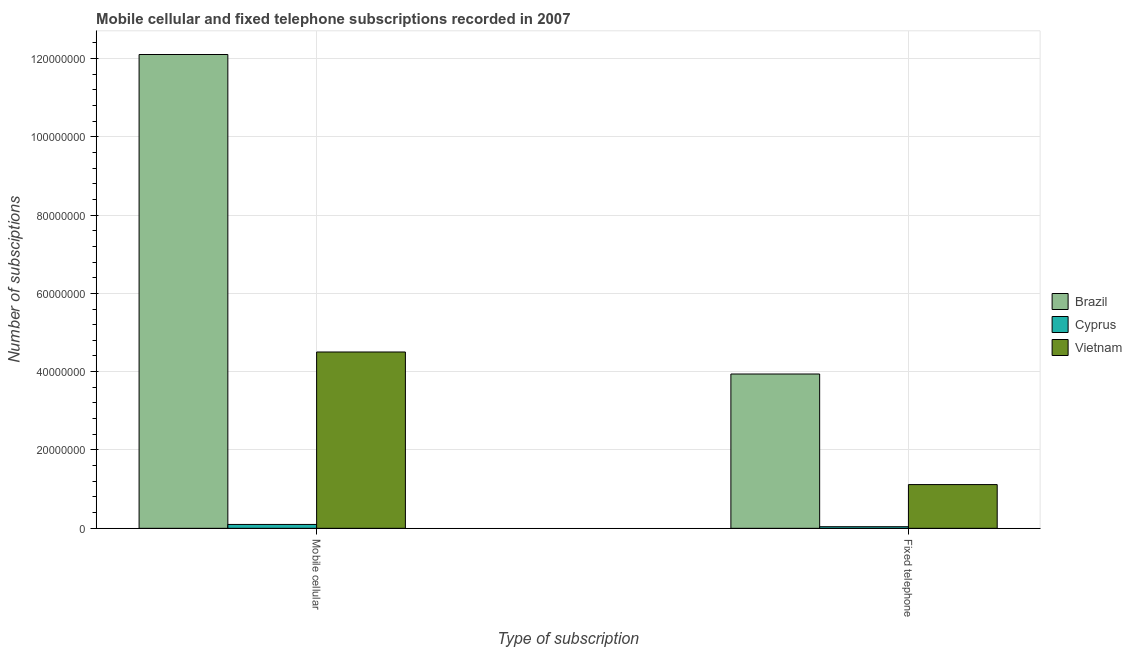How many different coloured bars are there?
Make the answer very short. 3. Are the number of bars per tick equal to the number of legend labels?
Your answer should be compact. Yes. How many bars are there on the 2nd tick from the left?
Offer a terse response. 3. What is the label of the 2nd group of bars from the left?
Offer a terse response. Fixed telephone. What is the number of mobile cellular subscriptions in Cyprus?
Your answer should be compact. 9.88e+05. Across all countries, what is the maximum number of fixed telephone subscriptions?
Your answer should be very brief. 3.94e+07. Across all countries, what is the minimum number of mobile cellular subscriptions?
Your answer should be compact. 9.88e+05. In which country was the number of fixed telephone subscriptions maximum?
Provide a succinct answer. Brazil. In which country was the number of mobile cellular subscriptions minimum?
Give a very brief answer. Cyprus. What is the total number of fixed telephone subscriptions in the graph?
Offer a terse response. 5.10e+07. What is the difference between the number of fixed telephone subscriptions in Vietnam and that in Brazil?
Keep it short and to the point. -2.82e+07. What is the difference between the number of fixed telephone subscriptions in Cyprus and the number of mobile cellular subscriptions in Brazil?
Provide a short and direct response. -1.21e+08. What is the average number of mobile cellular subscriptions per country?
Offer a very short reply. 5.57e+07. What is the difference between the number of mobile cellular subscriptions and number of fixed telephone subscriptions in Cyprus?
Your response must be concise. 5.79e+05. In how many countries, is the number of fixed telephone subscriptions greater than 52000000 ?
Offer a terse response. 0. What is the ratio of the number of fixed telephone subscriptions in Cyprus to that in Brazil?
Offer a terse response. 0.01. Is the number of mobile cellular subscriptions in Vietnam less than that in Brazil?
Provide a short and direct response. Yes. In how many countries, is the number of mobile cellular subscriptions greater than the average number of mobile cellular subscriptions taken over all countries?
Offer a very short reply. 1. What does the 3rd bar from the left in Mobile cellular represents?
Ensure brevity in your answer.  Vietnam. What does the 2nd bar from the right in Mobile cellular represents?
Provide a succinct answer. Cyprus. Are all the bars in the graph horizontal?
Provide a short and direct response. No. Are the values on the major ticks of Y-axis written in scientific E-notation?
Keep it short and to the point. No. Does the graph contain any zero values?
Make the answer very short. No. How many legend labels are there?
Keep it short and to the point. 3. What is the title of the graph?
Ensure brevity in your answer.  Mobile cellular and fixed telephone subscriptions recorded in 2007. Does "Turks and Caicos Islands" appear as one of the legend labels in the graph?
Your answer should be very brief. No. What is the label or title of the X-axis?
Make the answer very short. Type of subscription. What is the label or title of the Y-axis?
Offer a terse response. Number of subsciptions. What is the Number of subsciptions of Brazil in Mobile cellular?
Keep it short and to the point. 1.21e+08. What is the Number of subsciptions in Cyprus in Mobile cellular?
Your answer should be very brief. 9.88e+05. What is the Number of subsciptions in Vietnam in Mobile cellular?
Provide a succinct answer. 4.50e+07. What is the Number of subsciptions in Brazil in Fixed telephone?
Your response must be concise. 3.94e+07. What is the Number of subsciptions of Cyprus in Fixed telephone?
Provide a short and direct response. 4.09e+05. What is the Number of subsciptions in Vietnam in Fixed telephone?
Give a very brief answer. 1.12e+07. Across all Type of subscription, what is the maximum Number of subsciptions in Brazil?
Keep it short and to the point. 1.21e+08. Across all Type of subscription, what is the maximum Number of subsciptions of Cyprus?
Make the answer very short. 9.88e+05. Across all Type of subscription, what is the maximum Number of subsciptions of Vietnam?
Keep it short and to the point. 4.50e+07. Across all Type of subscription, what is the minimum Number of subsciptions of Brazil?
Your answer should be very brief. 3.94e+07. Across all Type of subscription, what is the minimum Number of subsciptions in Cyprus?
Your answer should be very brief. 4.09e+05. Across all Type of subscription, what is the minimum Number of subsciptions of Vietnam?
Your response must be concise. 1.12e+07. What is the total Number of subsciptions in Brazil in the graph?
Ensure brevity in your answer.  1.60e+08. What is the total Number of subsciptions of Cyprus in the graph?
Make the answer very short. 1.40e+06. What is the total Number of subsciptions in Vietnam in the graph?
Make the answer very short. 5.62e+07. What is the difference between the Number of subsciptions in Brazil in Mobile cellular and that in Fixed telephone?
Keep it short and to the point. 8.16e+07. What is the difference between the Number of subsciptions of Cyprus in Mobile cellular and that in Fixed telephone?
Give a very brief answer. 5.79e+05. What is the difference between the Number of subsciptions of Vietnam in Mobile cellular and that in Fixed telephone?
Make the answer very short. 3.39e+07. What is the difference between the Number of subsciptions of Brazil in Mobile cellular and the Number of subsciptions of Cyprus in Fixed telephone?
Make the answer very short. 1.21e+08. What is the difference between the Number of subsciptions in Brazil in Mobile cellular and the Number of subsciptions in Vietnam in Fixed telephone?
Give a very brief answer. 1.10e+08. What is the difference between the Number of subsciptions in Cyprus in Mobile cellular and the Number of subsciptions in Vietnam in Fixed telephone?
Your response must be concise. -1.02e+07. What is the average Number of subsciptions in Brazil per Type of subscription?
Your answer should be compact. 8.02e+07. What is the average Number of subsciptions of Cyprus per Type of subscription?
Provide a short and direct response. 6.99e+05. What is the average Number of subsciptions of Vietnam per Type of subscription?
Offer a terse response. 2.81e+07. What is the difference between the Number of subsciptions of Brazil and Number of subsciptions of Cyprus in Mobile cellular?
Your answer should be compact. 1.20e+08. What is the difference between the Number of subsciptions of Brazil and Number of subsciptions of Vietnam in Mobile cellular?
Keep it short and to the point. 7.60e+07. What is the difference between the Number of subsciptions in Cyprus and Number of subsciptions in Vietnam in Mobile cellular?
Your answer should be compact. -4.40e+07. What is the difference between the Number of subsciptions in Brazil and Number of subsciptions in Cyprus in Fixed telephone?
Offer a very short reply. 3.90e+07. What is the difference between the Number of subsciptions of Brazil and Number of subsciptions of Vietnam in Fixed telephone?
Your response must be concise. 2.82e+07. What is the difference between the Number of subsciptions of Cyprus and Number of subsciptions of Vietnam in Fixed telephone?
Provide a short and direct response. -1.08e+07. What is the ratio of the Number of subsciptions of Brazil in Mobile cellular to that in Fixed telephone?
Make the answer very short. 3.07. What is the ratio of the Number of subsciptions of Cyprus in Mobile cellular to that in Fixed telephone?
Offer a very short reply. 2.41. What is the ratio of the Number of subsciptions in Vietnam in Mobile cellular to that in Fixed telephone?
Your response must be concise. 4.03. What is the difference between the highest and the second highest Number of subsciptions in Brazil?
Your response must be concise. 8.16e+07. What is the difference between the highest and the second highest Number of subsciptions of Cyprus?
Offer a very short reply. 5.79e+05. What is the difference between the highest and the second highest Number of subsciptions of Vietnam?
Your response must be concise. 3.39e+07. What is the difference between the highest and the lowest Number of subsciptions of Brazil?
Provide a short and direct response. 8.16e+07. What is the difference between the highest and the lowest Number of subsciptions of Cyprus?
Keep it short and to the point. 5.79e+05. What is the difference between the highest and the lowest Number of subsciptions of Vietnam?
Ensure brevity in your answer.  3.39e+07. 